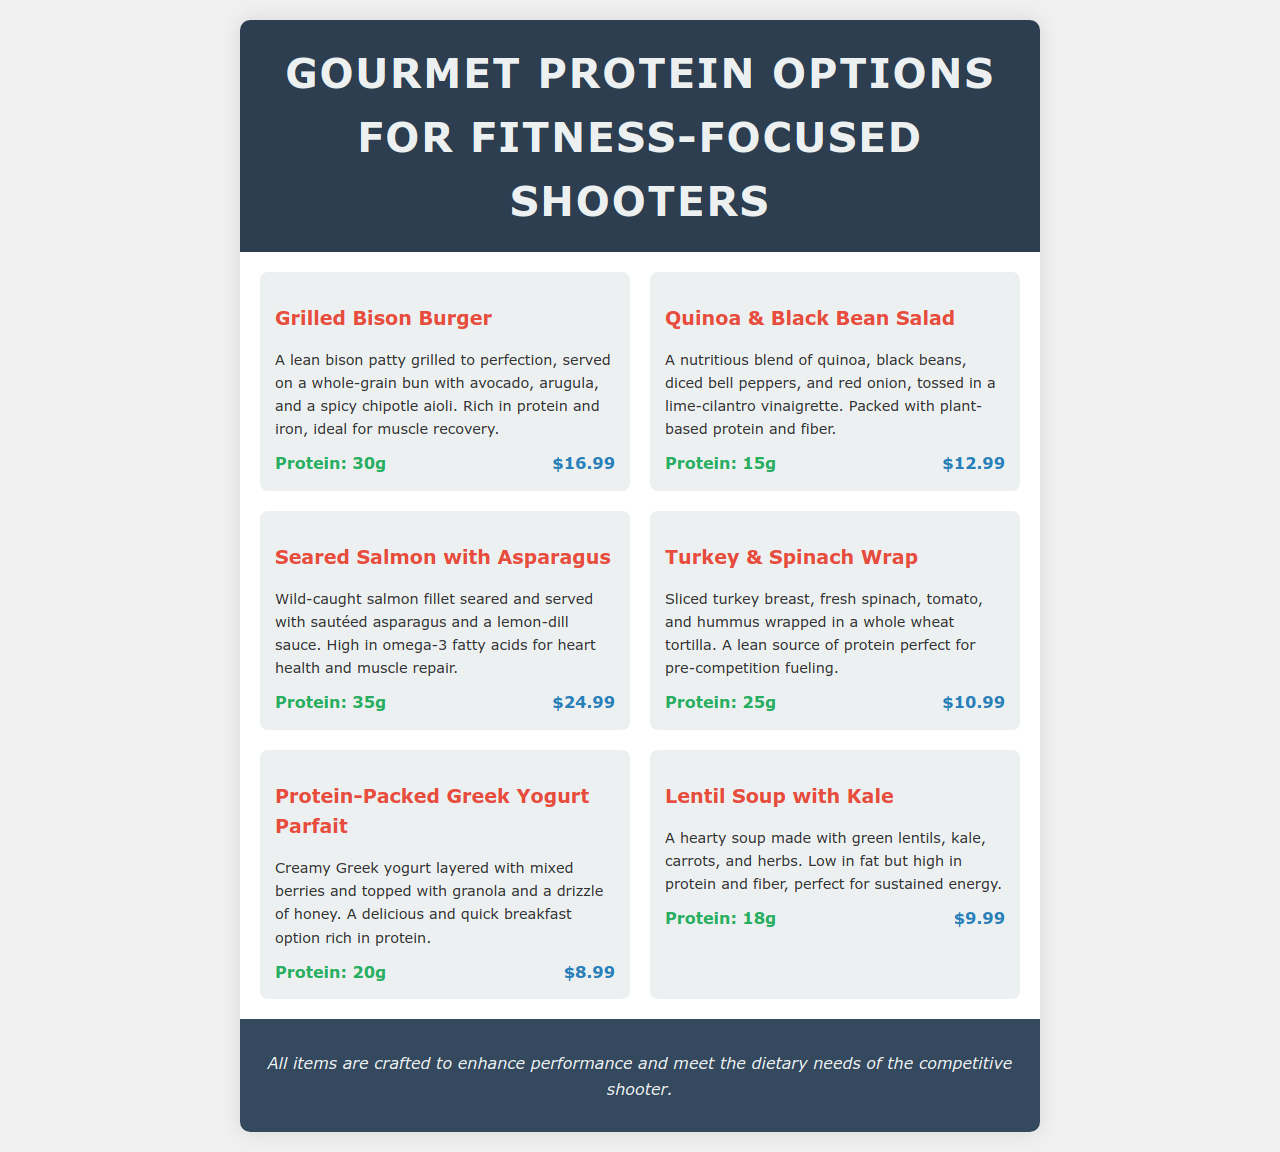What is the most protein-rich option? The option with the highest protein content is Seared Salmon with Asparagus, which contains 35g of protein.
Answer: Seared Salmon with Asparagus How much does the Quinoa & Black Bean Salad cost? The price listed for the Quinoa & Black Bean Salad is $12.99.
Answer: $12.99 What is the protein content of the Grilled Bison Burger? The Grilled Bison Burger contains 30g of protein, making it a good source of protein.
Answer: 30g Which dish is described as being good for muscle recovery? The Grilled Bison Burger is specifically noted for being rich in protein and iron, ideal for muscle recovery.
Answer: Grilled Bison Burger What type of wrap is included on the menu? The menu includes a Turkey & Spinach Wrap, which is a lean source of protein.
Answer: Turkey & Spinach Wrap Which menu item is a good option for breakfast? The Protein-Packed Greek Yogurt Parfait is highlighted as a quick breakfast option rich in protein.
Answer: Protein-Packed Greek Yogurt Parfait What are the main ingredients in the Lentil Soup? The Lentil Soup is made with green lentils, kale, carrots, and herbs, providing hearty nutrition.
Answer: Green lentils, kale, carrots, herbs How much does the Protein-Packed Greek Yogurt Parfait contribute in protein? The Protein-Packed Greek Yogurt Parfait contributes 20g of protein.
Answer: 20g Which dish is served with a spicy chipotle aioli? The Grilled Bison Burger is served with a spicy chipotle aioli.
Answer: Grilled Bison Burger 